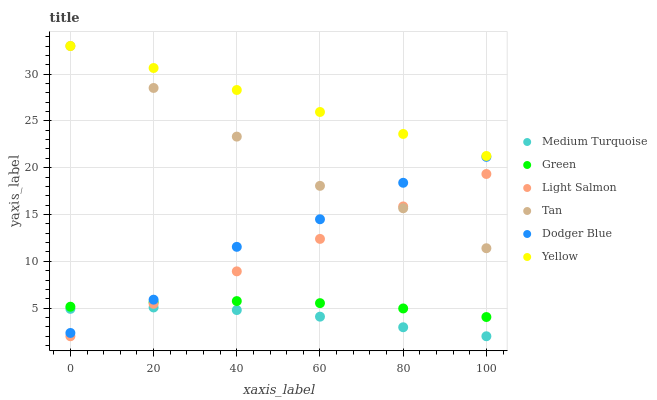Does Medium Turquoise have the minimum area under the curve?
Answer yes or no. Yes. Does Yellow have the maximum area under the curve?
Answer yes or no. Yes. Does Dodger Blue have the minimum area under the curve?
Answer yes or no. No. Does Dodger Blue have the maximum area under the curve?
Answer yes or no. No. Is Light Salmon the smoothest?
Answer yes or no. Yes. Is Dodger Blue the roughest?
Answer yes or no. Yes. Is Yellow the smoothest?
Answer yes or no. No. Is Yellow the roughest?
Answer yes or no. No. Does Light Salmon have the lowest value?
Answer yes or no. Yes. Does Dodger Blue have the lowest value?
Answer yes or no. No. Does Tan have the highest value?
Answer yes or no. Yes. Does Dodger Blue have the highest value?
Answer yes or no. No. Is Medium Turquoise less than Tan?
Answer yes or no. Yes. Is Dodger Blue greater than Light Salmon?
Answer yes or no. Yes. Does Medium Turquoise intersect Light Salmon?
Answer yes or no. Yes. Is Medium Turquoise less than Light Salmon?
Answer yes or no. No. Is Medium Turquoise greater than Light Salmon?
Answer yes or no. No. Does Medium Turquoise intersect Tan?
Answer yes or no. No. 